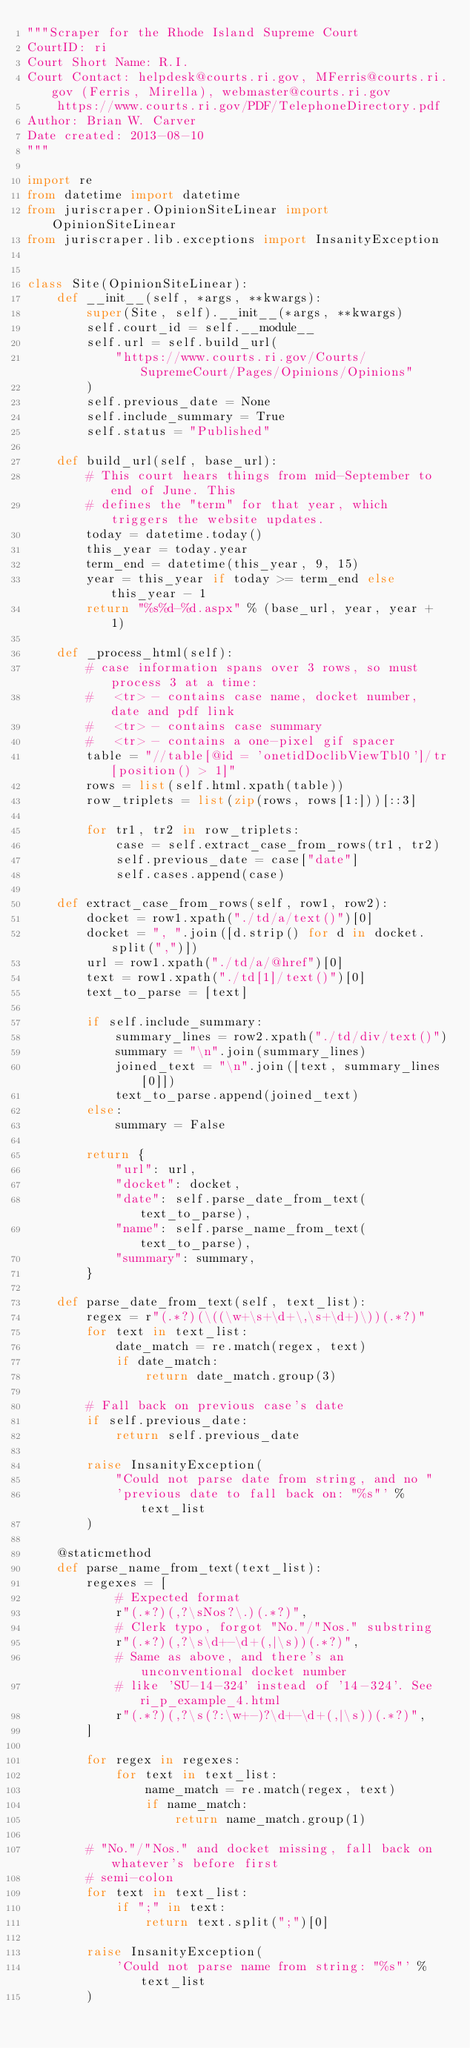<code> <loc_0><loc_0><loc_500><loc_500><_Python_>"""Scraper for the Rhode Island Supreme Court
CourtID: ri
Court Short Name: R.I.
Court Contact: helpdesk@courts.ri.gov, MFerris@courts.ri.gov (Ferris, Mirella), webmaster@courts.ri.gov
    https://www.courts.ri.gov/PDF/TelephoneDirectory.pdf
Author: Brian W. Carver
Date created: 2013-08-10
"""

import re
from datetime import datetime
from juriscraper.OpinionSiteLinear import OpinionSiteLinear
from juriscraper.lib.exceptions import InsanityException


class Site(OpinionSiteLinear):
    def __init__(self, *args, **kwargs):
        super(Site, self).__init__(*args, **kwargs)
        self.court_id = self.__module__
        self.url = self.build_url(
            "https://www.courts.ri.gov/Courts/SupremeCourt/Pages/Opinions/Opinions"
        )
        self.previous_date = None
        self.include_summary = True
        self.status = "Published"

    def build_url(self, base_url):
        # This court hears things from mid-September to end of June. This
        # defines the "term" for that year, which triggers the website updates.
        today = datetime.today()
        this_year = today.year
        term_end = datetime(this_year, 9, 15)
        year = this_year if today >= term_end else this_year - 1
        return "%s%d-%d.aspx" % (base_url, year, year + 1)

    def _process_html(self):
        # case information spans over 3 rows, so must process 3 at a time:
        #   <tr> - contains case name, docket number, date and pdf link
        #   <tr> - contains case summary
        #   <tr> - contains a one-pixel gif spacer
        table = "//table[@id = 'onetidDoclibViewTbl0']/tr[position() > 1]"
        rows = list(self.html.xpath(table))
        row_triplets = list(zip(rows, rows[1:]))[::3]

        for tr1, tr2 in row_triplets:
            case = self.extract_case_from_rows(tr1, tr2)
            self.previous_date = case["date"]
            self.cases.append(case)

    def extract_case_from_rows(self, row1, row2):
        docket = row1.xpath("./td/a/text()")[0]
        docket = ", ".join([d.strip() for d in docket.split(",")])
        url = row1.xpath("./td/a/@href")[0]
        text = row1.xpath("./td[1]/text()")[0]
        text_to_parse = [text]

        if self.include_summary:
            summary_lines = row2.xpath("./td/div/text()")
            summary = "\n".join(summary_lines)
            joined_text = "\n".join([text, summary_lines[0]])
            text_to_parse.append(joined_text)
        else:
            summary = False

        return {
            "url": url,
            "docket": docket,
            "date": self.parse_date_from_text(text_to_parse),
            "name": self.parse_name_from_text(text_to_parse),
            "summary": summary,
        }

    def parse_date_from_text(self, text_list):
        regex = r"(.*?)(\((\w+\s+\d+\,\s+\d+)\))(.*?)"
        for text in text_list:
            date_match = re.match(regex, text)
            if date_match:
                return date_match.group(3)

        # Fall back on previous case's date
        if self.previous_date:
            return self.previous_date

        raise InsanityException(
            "Could not parse date from string, and no "
            'previous date to fall back on: "%s"' % text_list
        )

    @staticmethod
    def parse_name_from_text(text_list):
        regexes = [
            # Expected format
            r"(.*?)(,?\sNos?\.)(.*?)",
            # Clerk typo, forgot "No."/"Nos." substring
            r"(.*?)(,?\s\d+-\d+(,|\s))(.*?)",
            # Same as above, and there's an unconventional docket number
            # like 'SU-14-324' instead of '14-324'. See ri_p_example_4.html
            r"(.*?)(,?\s(?:\w+-)?\d+-\d+(,|\s))(.*?)",
        ]

        for regex in regexes:
            for text in text_list:
                name_match = re.match(regex, text)
                if name_match:
                    return name_match.group(1)

        # "No."/"Nos." and docket missing, fall back on whatever's before first
        # semi-colon
        for text in text_list:
            if ";" in text:
                return text.split(";")[0]

        raise InsanityException(
            'Could not parse name from string: "%s"' % text_list
        )
</code> 